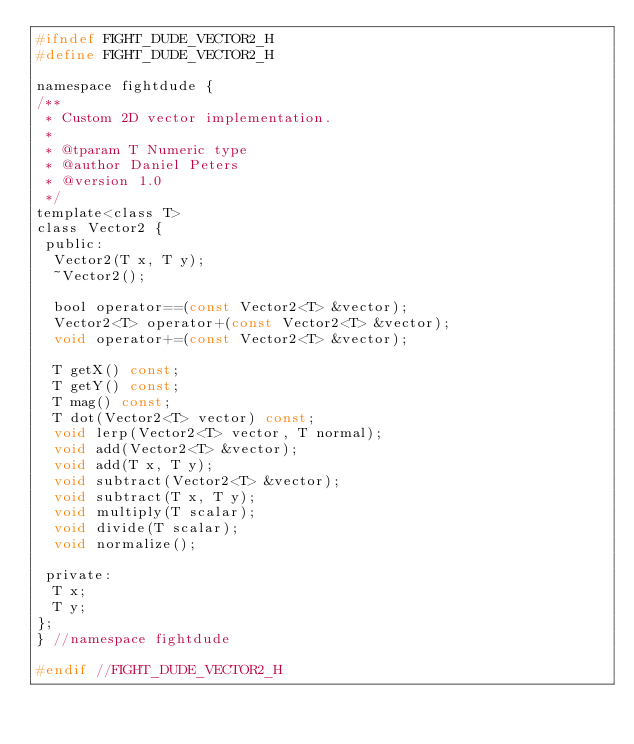Convert code to text. <code><loc_0><loc_0><loc_500><loc_500><_C_>#ifndef FIGHT_DUDE_VECTOR2_H
#define FIGHT_DUDE_VECTOR2_H

namespace fightdude {
/**
 * Custom 2D vector implementation.
 *
 * @tparam T Numeric type
 * @author Daniel Peters
 * @version 1.0
 */
template<class T>
class Vector2 {
 public:
  Vector2(T x, T y);
  ~Vector2();

  bool operator==(const Vector2<T> &vector);
  Vector2<T> operator+(const Vector2<T> &vector);
  void operator+=(const Vector2<T> &vector);

  T getX() const;
  T getY() const;
  T mag() const;
  T dot(Vector2<T> vector) const;
  void lerp(Vector2<T> vector, T normal);
  void add(Vector2<T> &vector);
  void add(T x, T y);
  void subtract(Vector2<T> &vector);
  void subtract(T x, T y);
  void multiply(T scalar);
  void divide(T scalar);
  void normalize();

 private:
  T x;
  T y;
};
} //namespace fightdude

#endif //FIGHT_DUDE_VECTOR2_H
</code> 